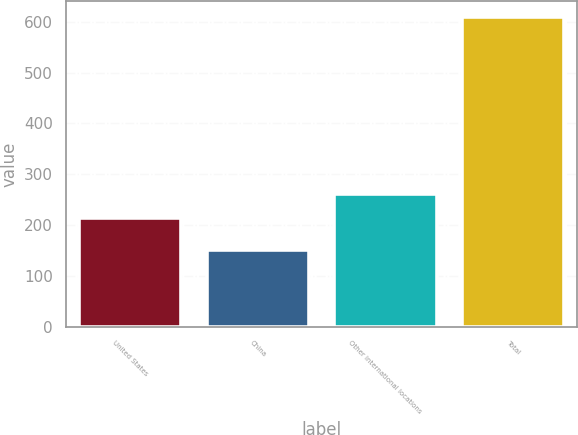Convert chart. <chart><loc_0><loc_0><loc_500><loc_500><bar_chart><fcel>United States<fcel>China<fcel>Other international locations<fcel>Total<nl><fcel>214.4<fcel>151.4<fcel>260.21<fcel>609.5<nl></chart> 